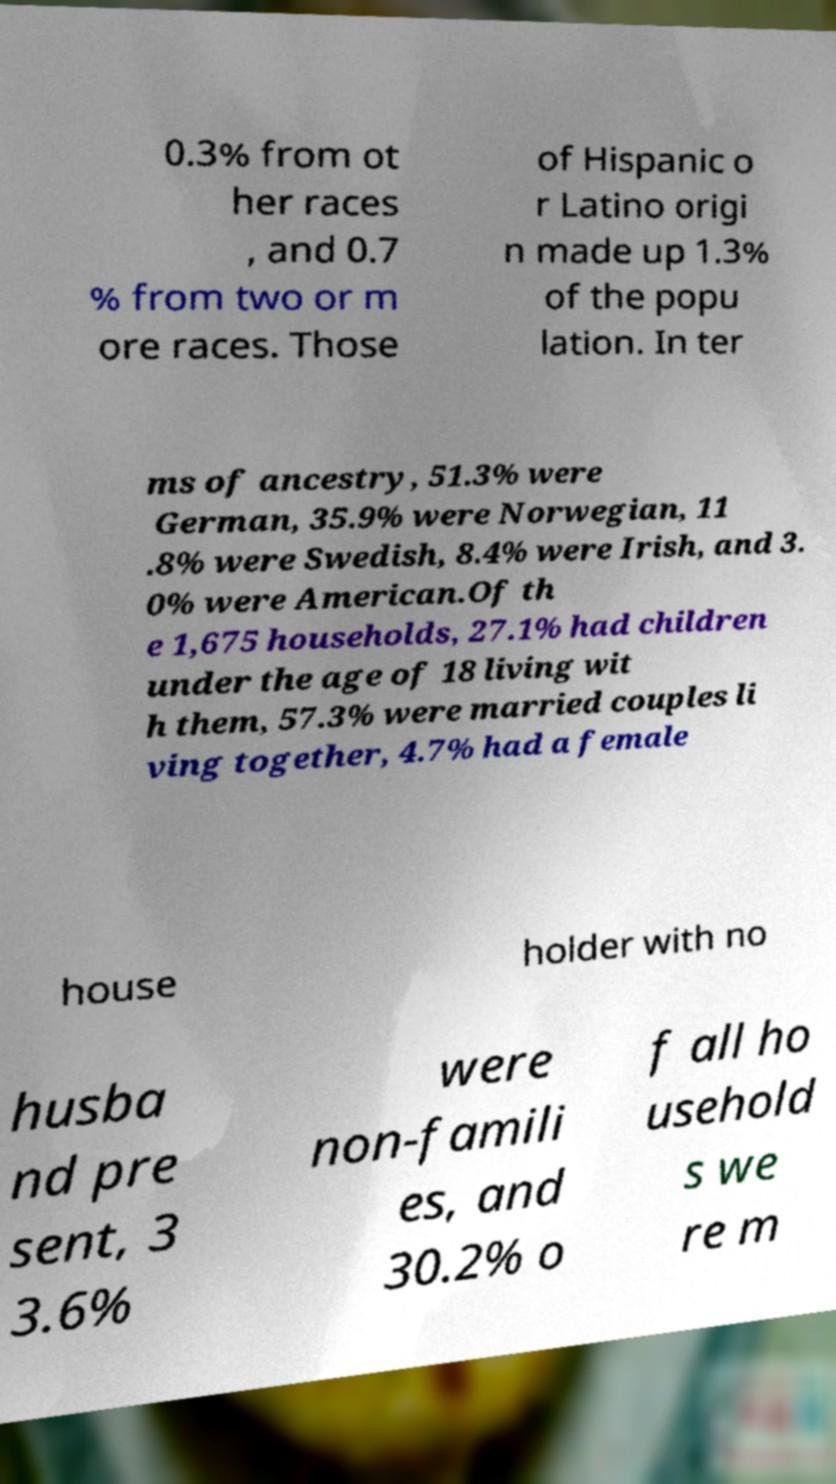Please read and relay the text visible in this image. What does it say? 0.3% from ot her races , and 0.7 % from two or m ore races. Those of Hispanic o r Latino origi n made up 1.3% of the popu lation. In ter ms of ancestry, 51.3% were German, 35.9% were Norwegian, 11 .8% were Swedish, 8.4% were Irish, and 3. 0% were American.Of th e 1,675 households, 27.1% had children under the age of 18 living wit h them, 57.3% were married couples li ving together, 4.7% had a female house holder with no husba nd pre sent, 3 3.6% were non-famili es, and 30.2% o f all ho usehold s we re m 